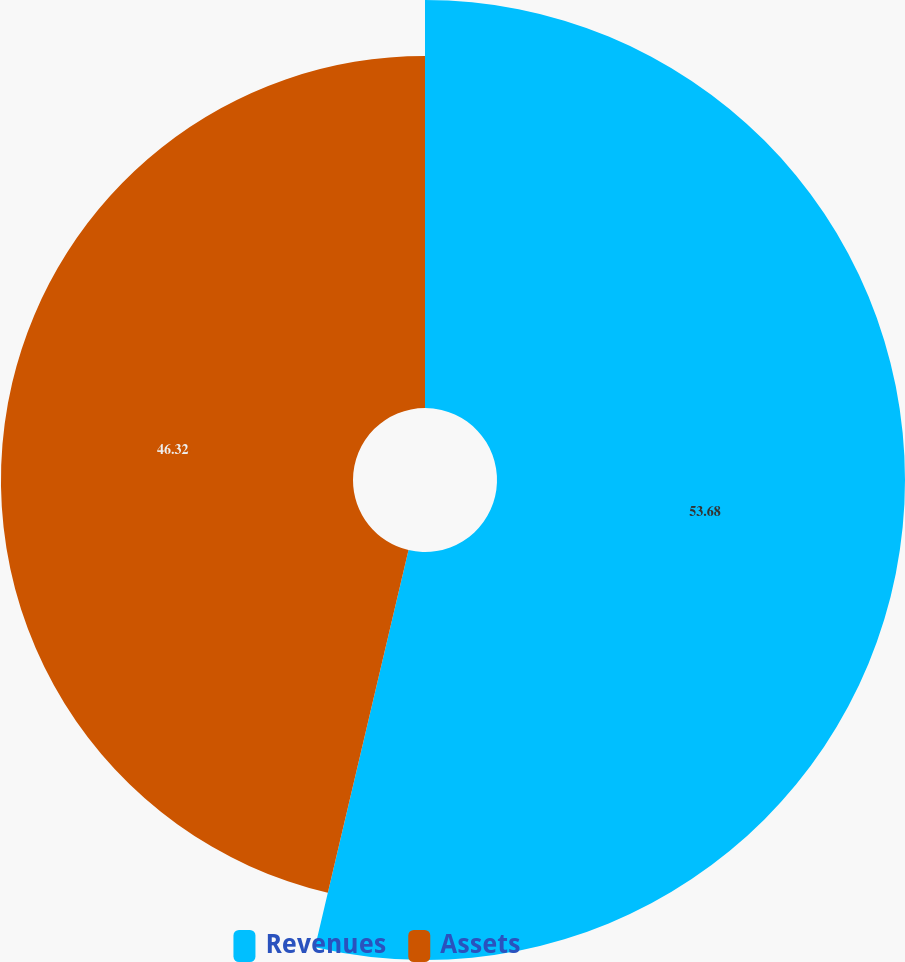<chart> <loc_0><loc_0><loc_500><loc_500><pie_chart><fcel>Revenues<fcel>Assets<nl><fcel>53.68%<fcel>46.32%<nl></chart> 